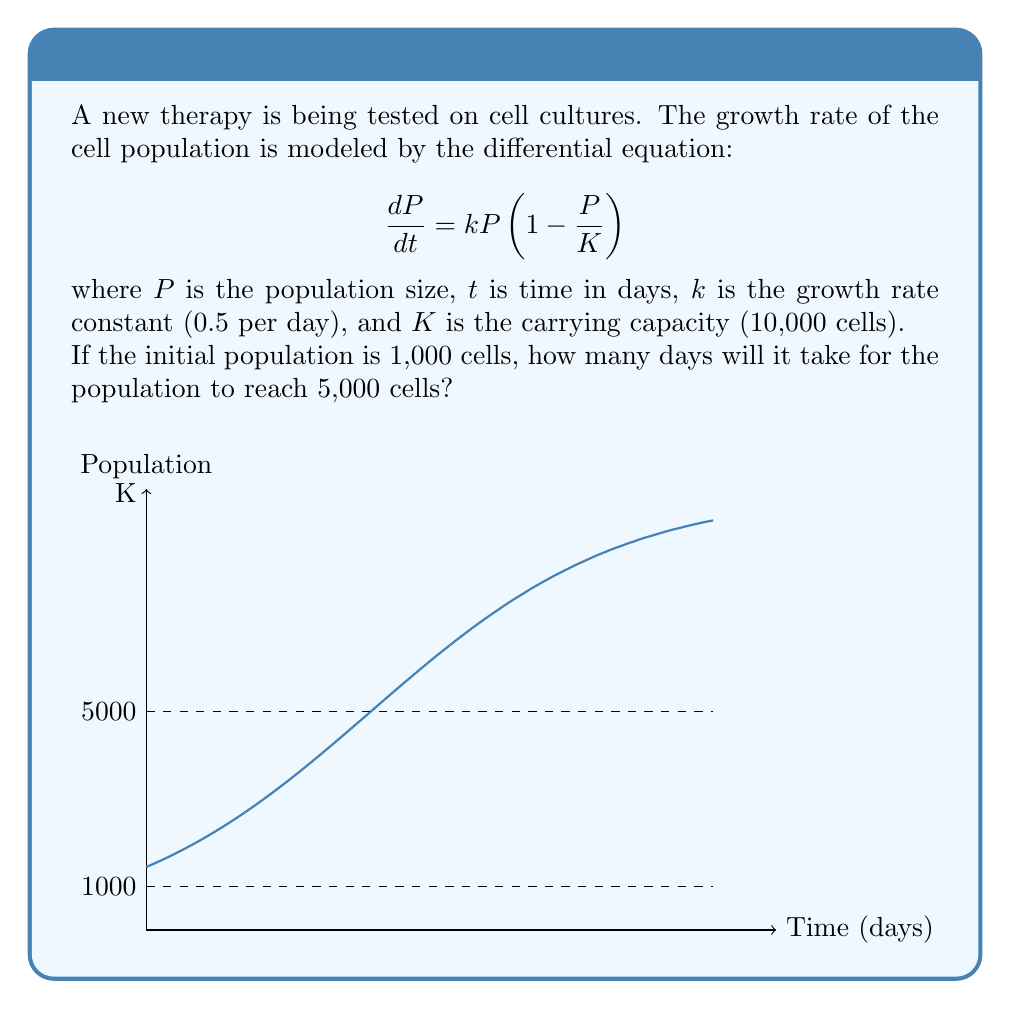Can you solve this math problem? To solve this problem, we need to follow these steps:

1) The given differential equation is a logistic growth model. Its solution is:

   $$P(t) = \frac{K}{1 + (\frac{K}{P_0} - 1)e^{-kt}}$$

   where $P_0$ is the initial population.

2) We're given:
   $K = 10,000$
   $k = 0.5$
   $P_0 = 1,000$
   $P(t) = 5,000$ (the target population)

3) Let's substitute these values into the equation:

   $$5,000 = \frac{10,000}{1 + (\frac{10,000}{1,000} - 1)e^{-0.5t}}$$

4) Simplify:

   $$5,000 = \frac{10,000}{1 + 9e^{-0.5t}}$$

5) Multiply both sides by $(1 + 9e^{-0.5t})$:

   $$5,000(1 + 9e^{-0.5t}) = 10,000$$

6) Distribute:

   $$5,000 + 45,000e^{-0.5t} = 10,000$$

7) Subtract 5,000 from both sides:

   $$45,000e^{-0.5t} = 5,000$$

8) Divide both sides by 45,000:

   $$e^{-0.5t} = \frac{1}{9}$$

9) Take the natural log of both sides:

   $$-0.5t = \ln(\frac{1}{9})$$

10) Divide both sides by -0.5:

    $$t = -\frac{2\ln(\frac{1}{9})}{1} = 2\ln(9) \approx 4.39$$

Therefore, it will take approximately 4.39 days for the population to reach 5,000 cells.
Answer: 4.39 days 